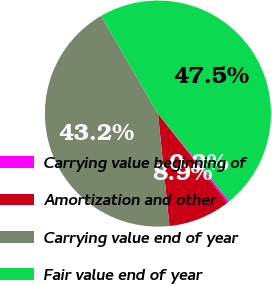<chart> <loc_0><loc_0><loc_500><loc_500><pie_chart><fcel>Carrying value beginning of<fcel>Amortization and other<fcel>Carrying value end of year<fcel>Fair value end of year<nl><fcel>0.31%<fcel>8.92%<fcel>43.23%<fcel>47.54%<nl></chart> 